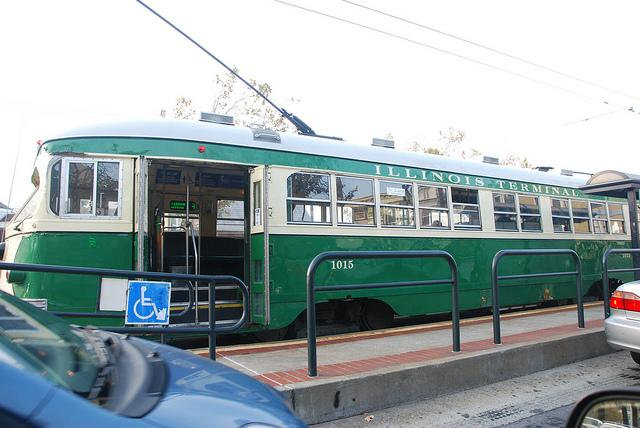What is available according to the blue sign?

Choices:
A) snacks
B) bathrooms
C) movies
D) handicap seats handicap seats 